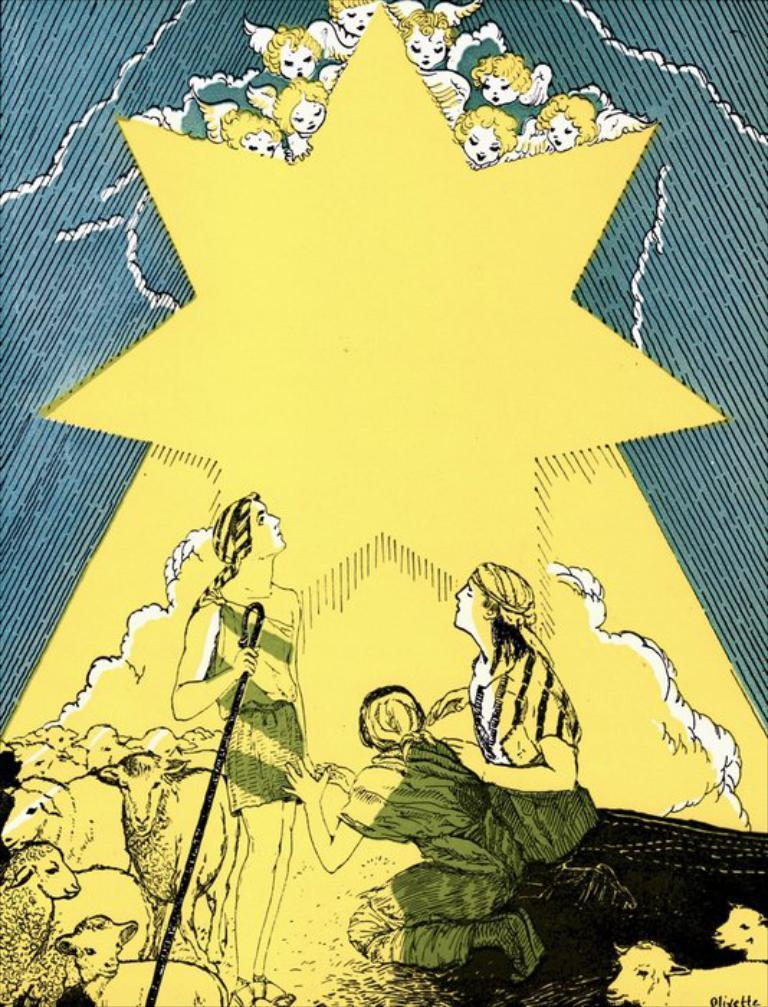What is present in the image that features images? There is a poster in the image that contains images. What types of images can be seen on the poster? The poster contains images of people and animals. How does the poster contribute to reducing pollution in the image? The poster does not contribute to reducing pollution in the image, as there is no mention of pollution in the provided facts. 